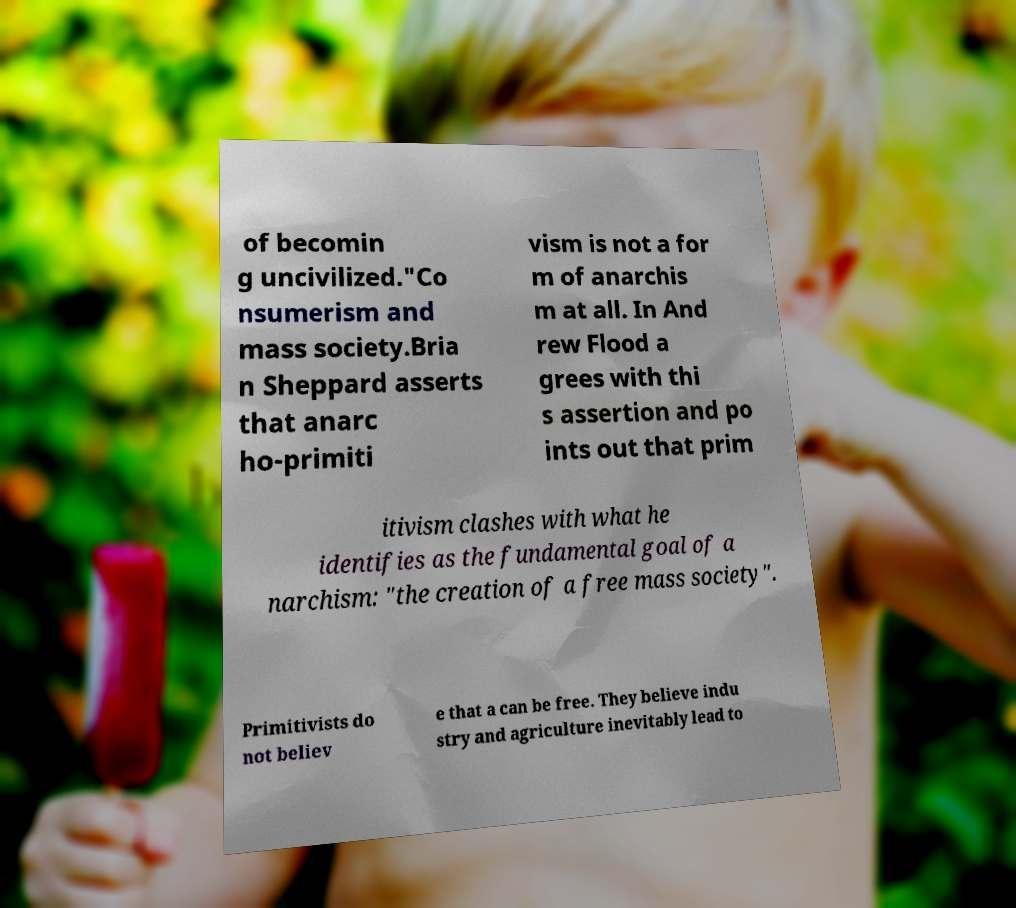What messages or text are displayed in this image? I need them in a readable, typed format. of becomin g uncivilized."Co nsumerism and mass society.Bria n Sheppard asserts that anarc ho-primiti vism is not a for m of anarchis m at all. In And rew Flood a grees with thi s assertion and po ints out that prim itivism clashes with what he identifies as the fundamental goal of a narchism: "the creation of a free mass society". Primitivists do not believ e that a can be free. They believe indu stry and agriculture inevitably lead to 